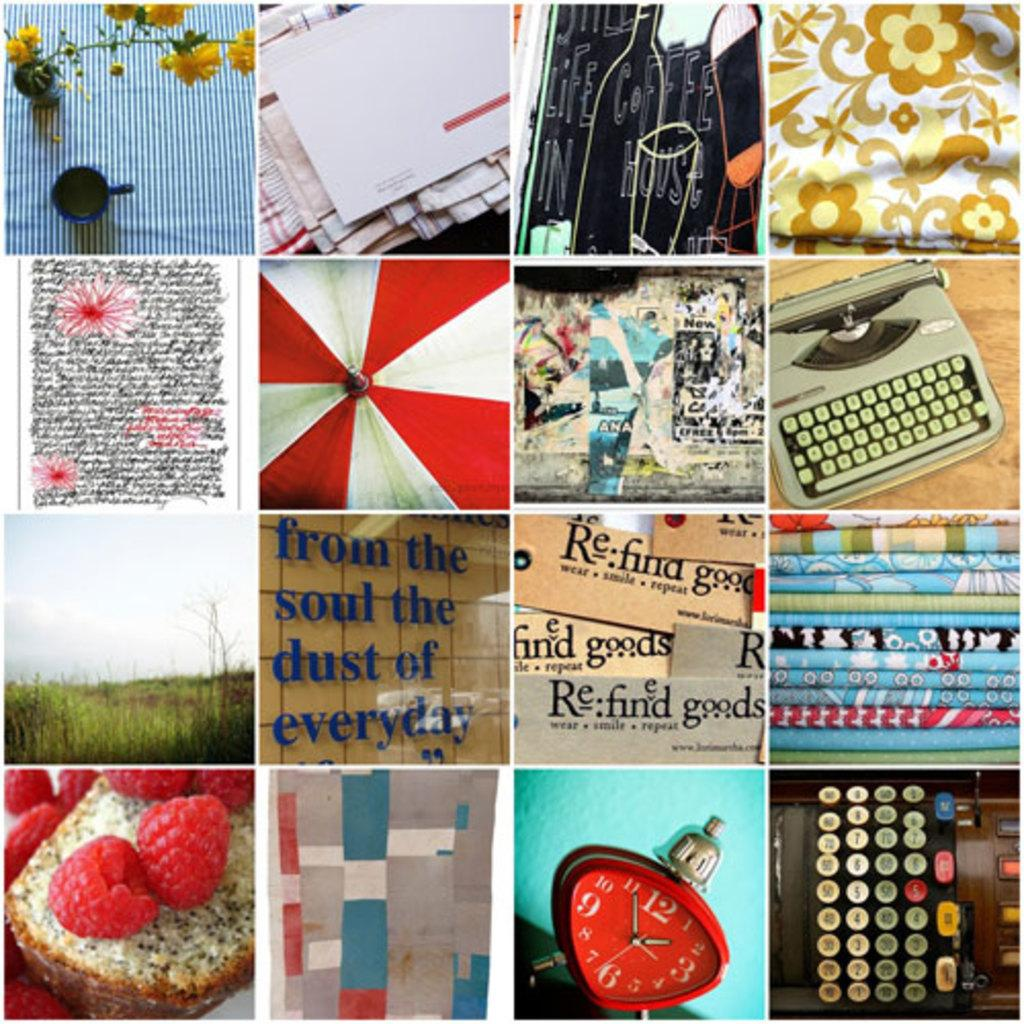<image>
Relay a brief, clear account of the picture shown. Collage of photos with one saying "Refind Goods". 